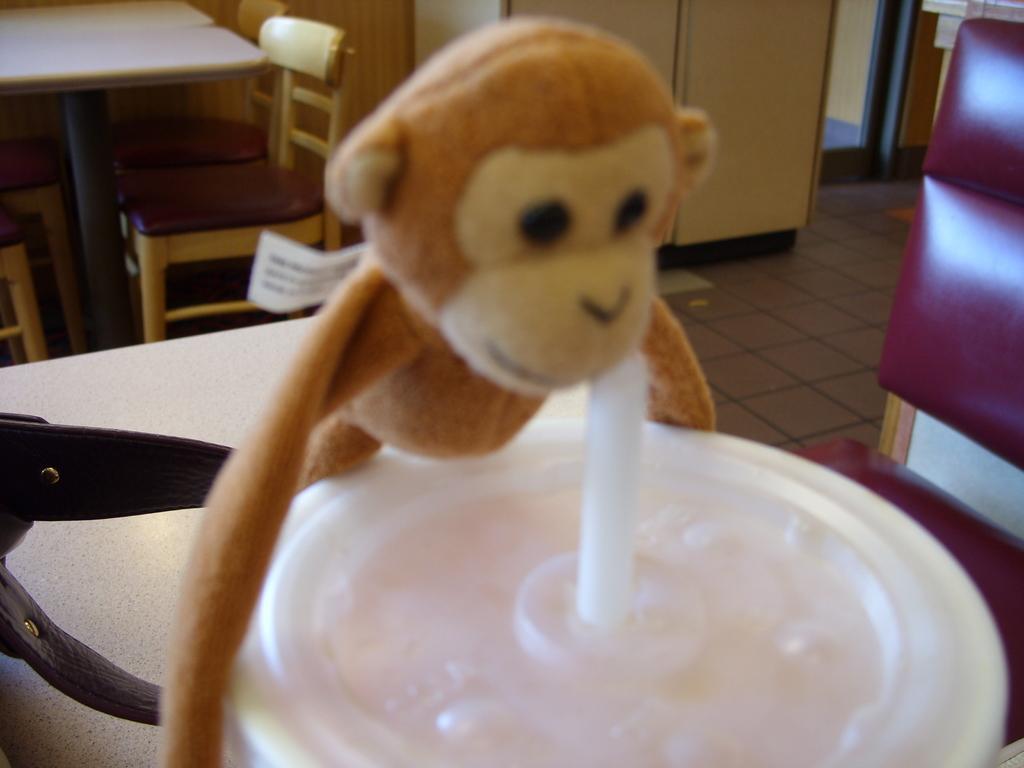In one or two sentences, can you explain what this image depicts? In the picture we can see a monkey doll and a glass with straw kept near it, on the table, the table is white in color, and two chairs are placed near the table and the background we can see a cupboard, table and chairs with the floor which is brown in color. 